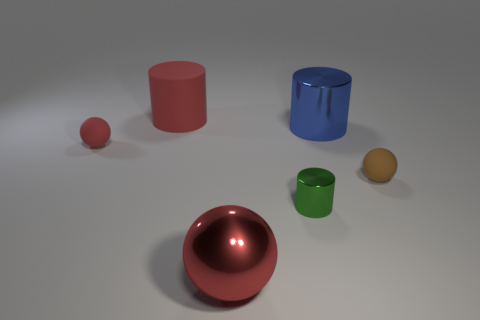Add 2 large brown rubber spheres. How many objects exist? 8 Subtract all tiny balls. Subtract all big things. How many objects are left? 1 Add 4 blue cylinders. How many blue cylinders are left? 5 Add 5 cylinders. How many cylinders exist? 8 Subtract 0 purple cylinders. How many objects are left? 6 